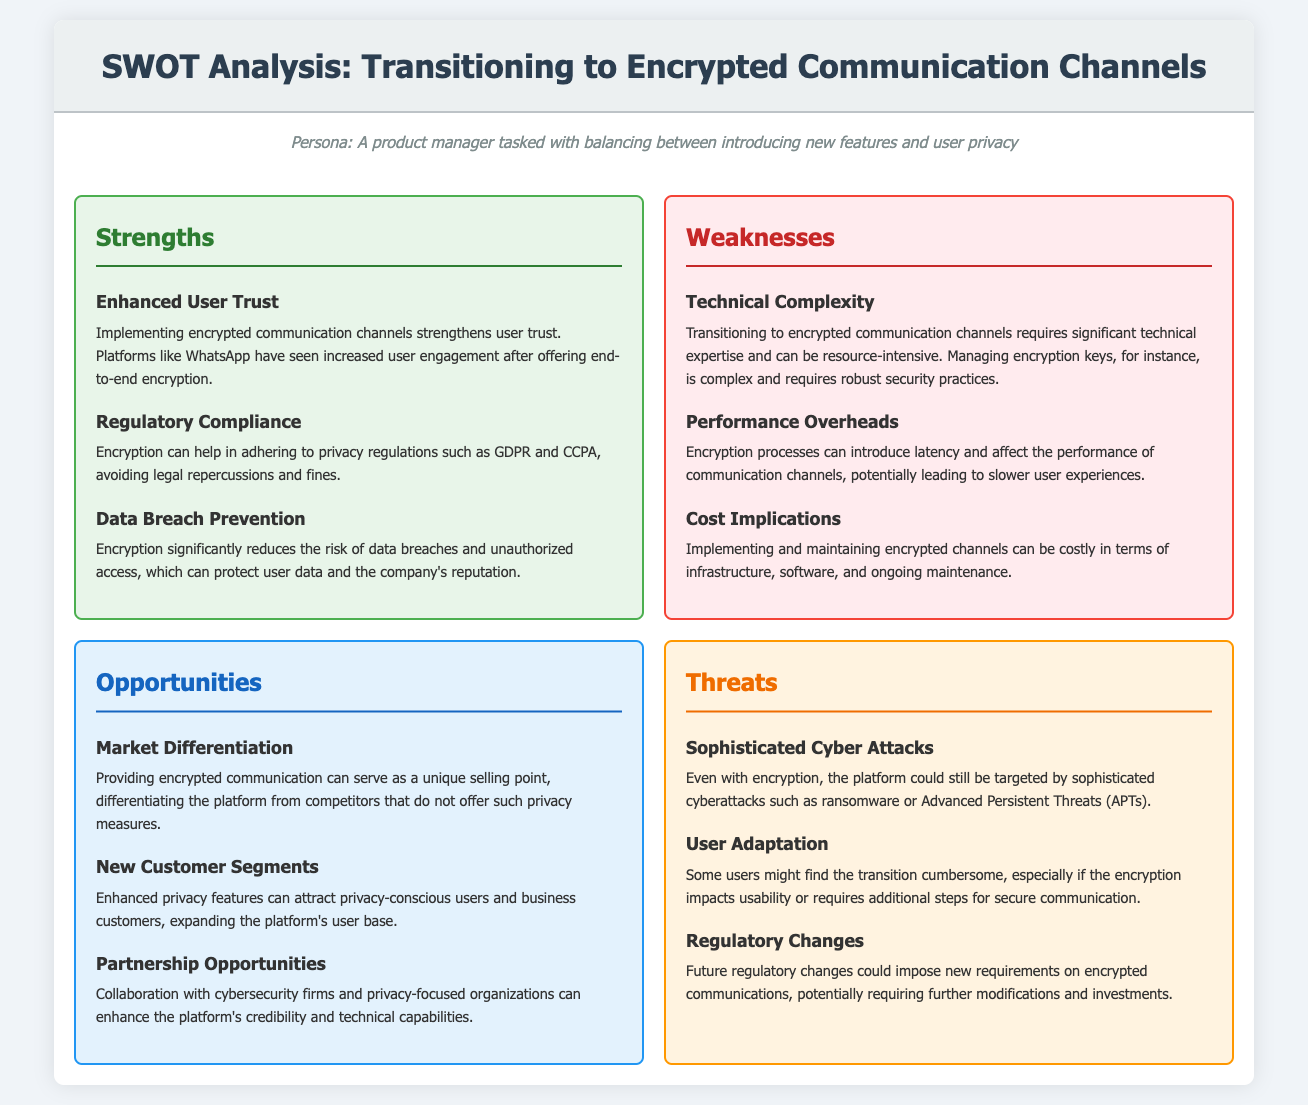What is an example of a strength related to user engagement? Enhanced User Trust strengthens user trust and can lead to increased user engagement.
Answer: Enhanced User Trust What is one of the weaknesses related to technical requirements? Transitioning to encrypted communication channels requires significant technical expertise.
Answer: Technical Complexity What opportunity could offer a unique selling point? Providing encrypted communication can serve as a unique selling point.
Answer: Market Differentiation What is a threat posed by user behavior? Some users might find the transition cumbersome and affect usability.
Answer: User Adaptation How can encryption assist regarding regulations? Encryption can help in adhering to privacy regulations such as GDPR and CCPA.
Answer: Regulatory Compliance What is a cost-related weakness of transitioning to encrypted communication? Implementing and maintaining encrypted channels can be costly.
Answer: Cost Implications 